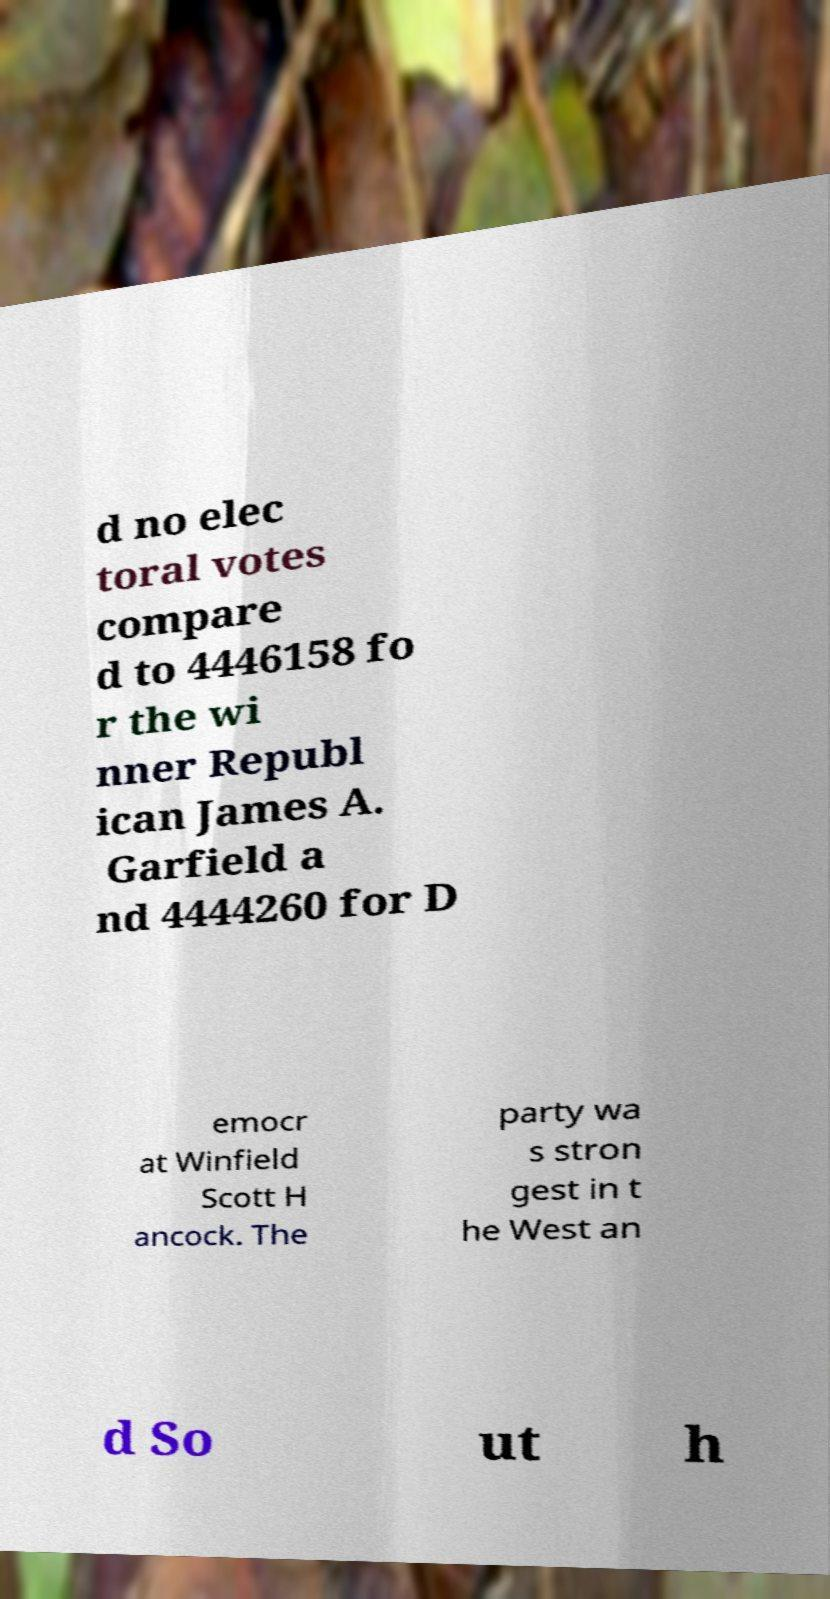Can you read and provide the text displayed in the image?This photo seems to have some interesting text. Can you extract and type it out for me? d no elec toral votes compare d to 4446158 fo r the wi nner Republ ican James A. Garfield a nd 4444260 for D emocr at Winfield Scott H ancock. The party wa s stron gest in t he West an d So ut h 